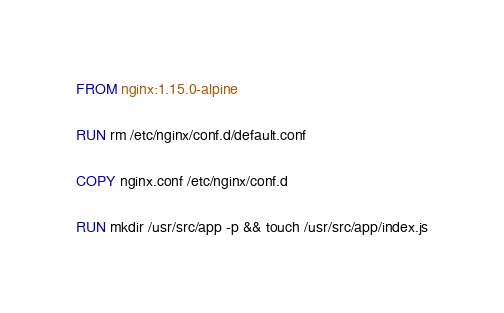<code> <loc_0><loc_0><loc_500><loc_500><_Dockerfile_>FROM nginx:1.15.0-alpine

RUN rm /etc/nginx/conf.d/default.conf

COPY nginx.conf /etc/nginx/conf.d

RUN mkdir /usr/src/app -p && touch /usr/src/app/index.js
</code> 